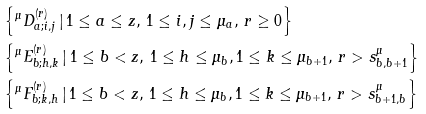Convert formula to latex. <formula><loc_0><loc_0><loc_500><loc_500>& \left \{ ^ { \mu } D _ { a ; i , j } ^ { ( r ) } \, | \, { 1 \leq a \leq z , \, 1 \leq i , j \leq \mu _ { a } , \, r \geq 0 } \right \} \\ & \left \{ ^ { \mu } E _ { b ; h , k } ^ { ( r ) } \, | \, { 1 \leq b < z , \, 1 \leq h \leq \mu _ { b } , 1 \leq k \leq \mu _ { b + 1 } , \, r > s _ { b , b + 1 } ^ { \mu } } \right \} \\ & \left \{ ^ { \mu } F _ { b ; k , h } ^ { ( r ) } \, | \, { 1 \leq b < z , \, 1 \leq h \leq \mu _ { b } , 1 \leq k \leq \mu _ { b + 1 } , \, r > s _ { b + 1 , b } ^ { \mu } } \right \}</formula> 